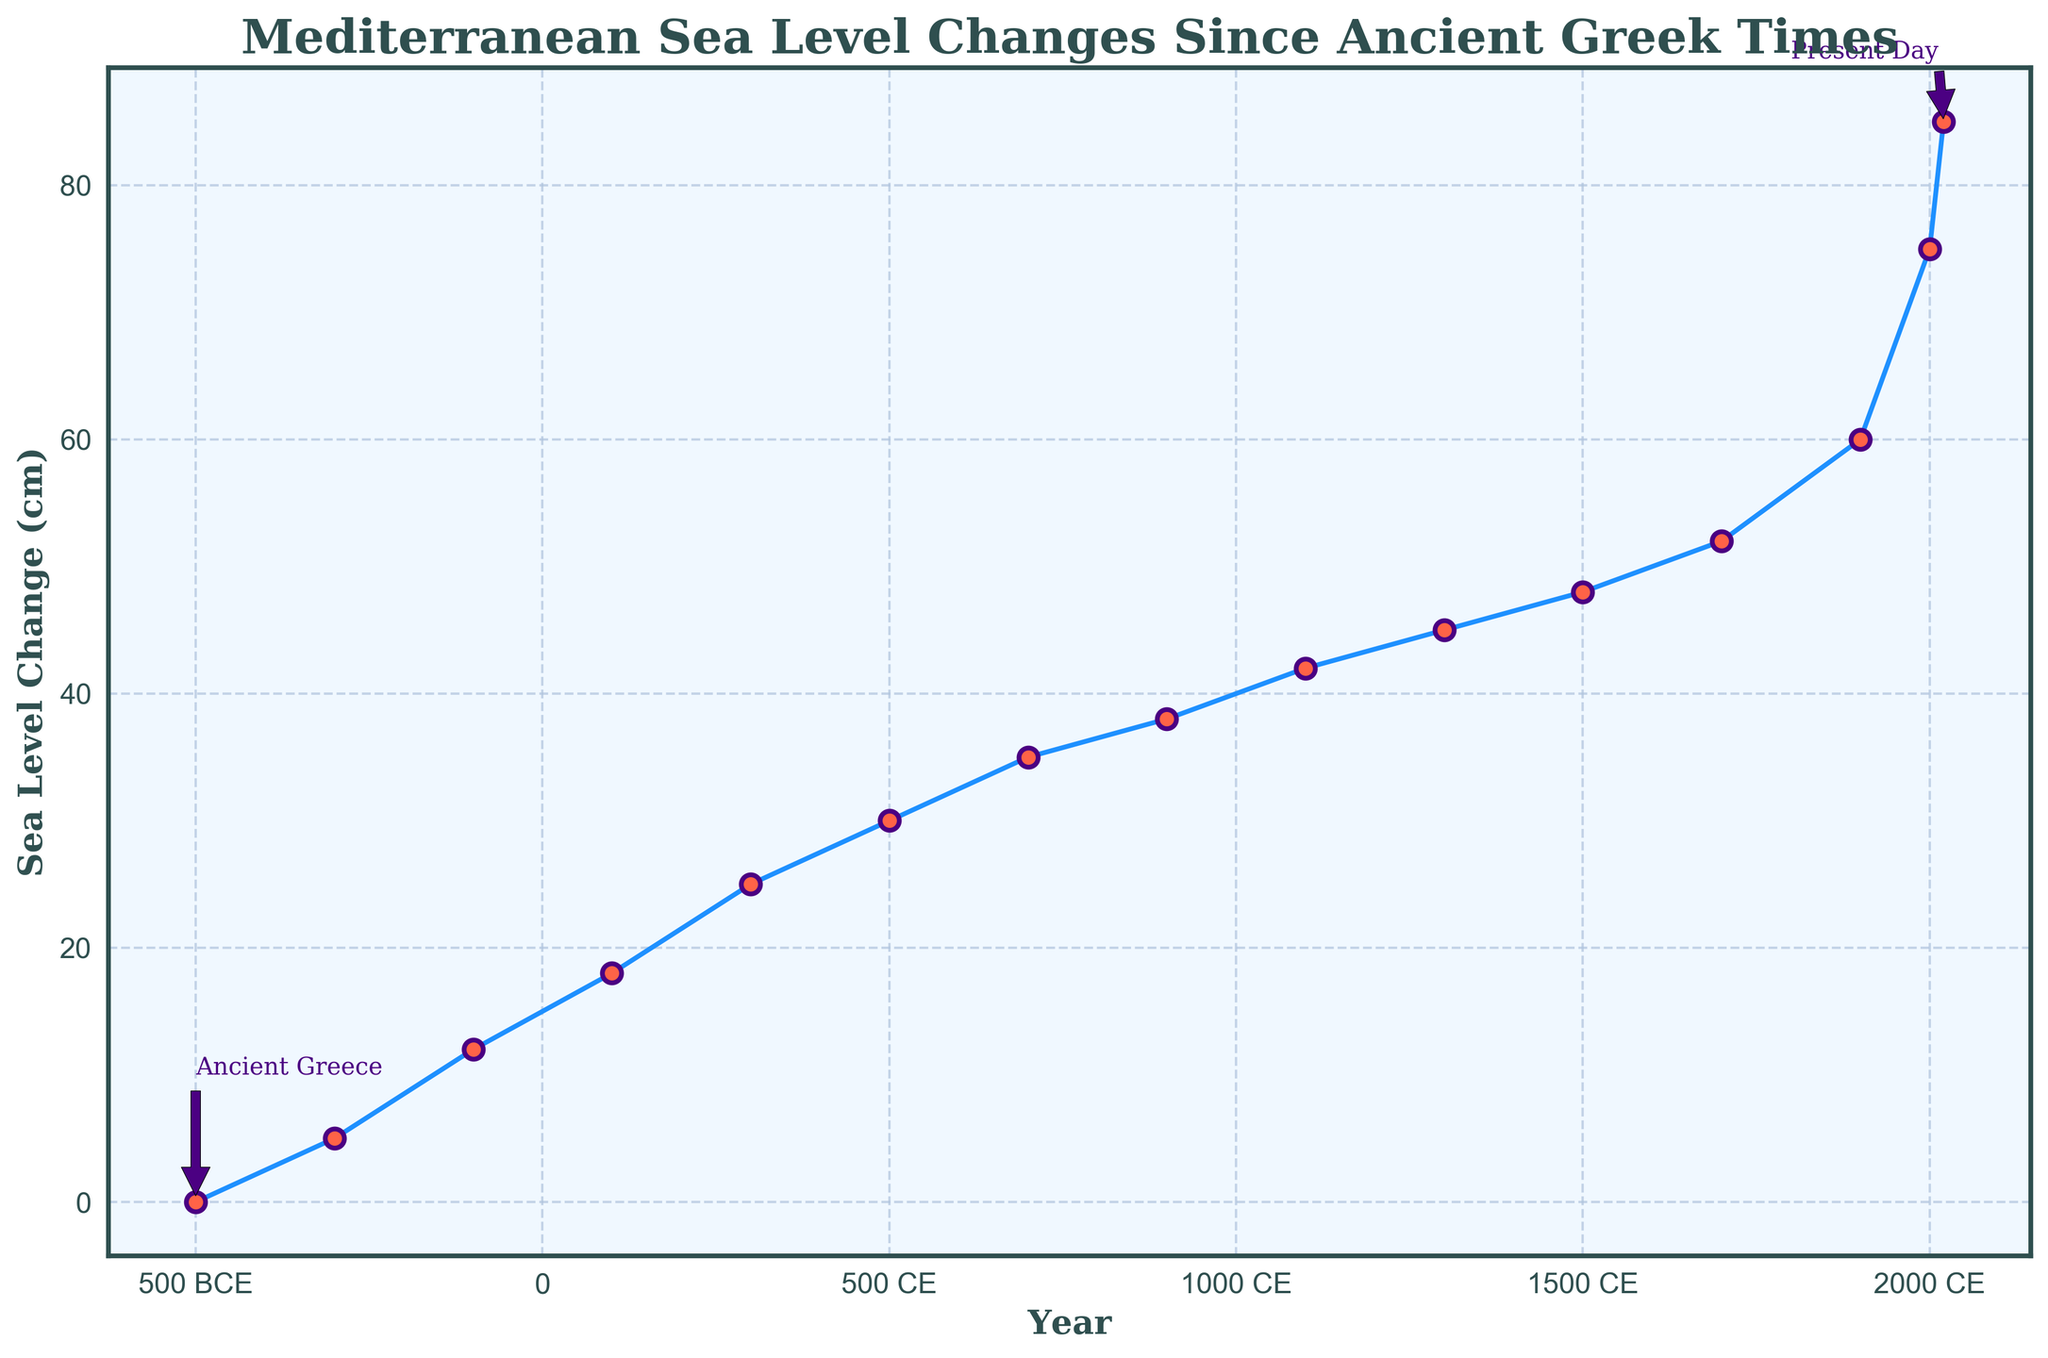What is the sea level change in the year 100 CE? The year 100 CE is represented by a point on the line chart. Locate this point on the x-axis (year) and identify the corresponding y-axis value (sea level change).
Answer: 18 cm Between 500 BCE and 300 CE, how much did the sea level change? Find the sea level change at 500 BCE (0 cm) and at 300 CE (25 cm). Subtract the earlier value from the later value (25 - 0).
Answer: 25 cm During which century did the sea level change from 48 cm to 52 cm occur? Identify the years where 48 cm and 52 cm are plotted on the chart (1500 CE and 1700 CE). The sea level change occurred between these years, specifically in the 16th to 17th century.
Answer: 16th - 17th century Compare the sea level changes between 100 BCE and 100 CE. Which one had a greater increase? Locate sea level changes for 100 BCE (12 cm) and 100 CE (18 cm). Calculate the differences from the previous measurements (7 cm increase for 100 BCE to 100 CE). Since both involve increasing patterns, compare the absolute changes.
Answer: Both increased equally In which period did the sea level remain nearly constant for the longest duration? Observe the plot for extended periods of minimal sea level change. Notice that from 900 CE (38 cm) to 1100 CE (42 cm), the increase is only 4 cm over 200 years, which appears as a relatively flat section on the graph.
Answer: 900 CE to 1100 CE What visual cue indicates the starting and ending points on the plot? The plot's annotations highlight the text 'Ancient Greece' and 'Present Day' at the beginning (-500, 0) and farthest right (2020, 85) points, with arrows pointing from the text to their respective data points.
Answer: Annotated arrows What is the average sea level change per century from 1700 CE to 2020 CE? First, determine the total change from 1700 CE (52 cm) to 2020 CE (85 cm), which is (85 - 52 = 33 cm). Determine the number of centuries involved (2020 - 1700 = 320 years, or 3.2 centuries). Divide the total change by the number of centuries (33 cm / 3.2).
Answer: ~10.31 cm/century Which two consecutive centuries show the highest sea level change difference? Analyze the sea level data points and consecutive changes: notable increases happen during 1900 CE (60 cm) to 2000 CE (75 cm), giving a difference of 15 cm which is the highest.
Answer: 1900 CE - 2000 CE What historical timeline period shows the smallest sea level change difference between any two points? Focus on periods with minimal difference, such as 1100 CE (42 cm) to 1300 CE (45 cm) with only a 3 cm change.
Answer: 1100 CE - 1300 CE 